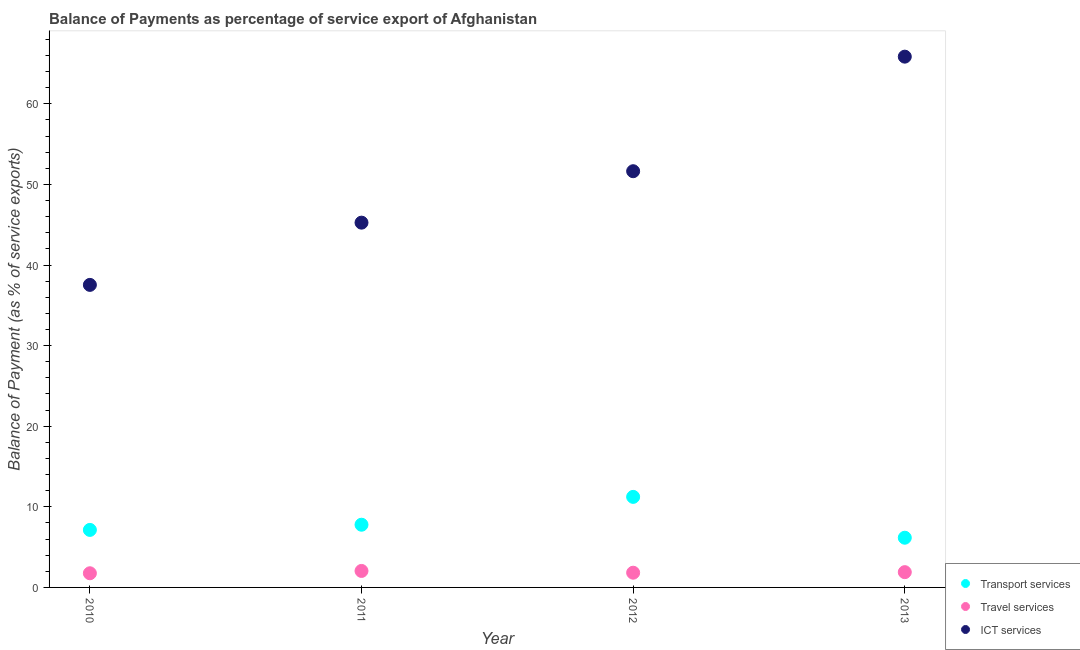How many different coloured dotlines are there?
Give a very brief answer. 3. Is the number of dotlines equal to the number of legend labels?
Keep it short and to the point. Yes. What is the balance of payment of travel services in 2011?
Provide a short and direct response. 2.05. Across all years, what is the maximum balance of payment of transport services?
Make the answer very short. 11.23. Across all years, what is the minimum balance of payment of travel services?
Give a very brief answer. 1.76. In which year was the balance of payment of travel services minimum?
Offer a very short reply. 2010. What is the total balance of payment of transport services in the graph?
Keep it short and to the point. 32.32. What is the difference between the balance of payment of ict services in 2011 and that in 2013?
Offer a very short reply. -20.59. What is the difference between the balance of payment of travel services in 2011 and the balance of payment of ict services in 2013?
Provide a succinct answer. -63.81. What is the average balance of payment of ict services per year?
Your response must be concise. 50.07. In the year 2013, what is the difference between the balance of payment of ict services and balance of payment of transport services?
Offer a terse response. 59.68. In how many years, is the balance of payment of travel services greater than 62 %?
Offer a terse response. 0. What is the ratio of the balance of payment of ict services in 2011 to that in 2013?
Offer a very short reply. 0.69. Is the difference between the balance of payment of travel services in 2011 and 2012 greater than the difference between the balance of payment of transport services in 2011 and 2012?
Give a very brief answer. Yes. What is the difference between the highest and the second highest balance of payment of ict services?
Offer a terse response. 14.21. What is the difference between the highest and the lowest balance of payment of ict services?
Your answer should be compact. 28.32. Is the sum of the balance of payment of travel services in 2010 and 2012 greater than the maximum balance of payment of ict services across all years?
Offer a terse response. No. Is it the case that in every year, the sum of the balance of payment of transport services and balance of payment of travel services is greater than the balance of payment of ict services?
Your answer should be very brief. No. Is the balance of payment of ict services strictly greater than the balance of payment of transport services over the years?
Keep it short and to the point. Yes. Is the balance of payment of travel services strictly less than the balance of payment of transport services over the years?
Your answer should be compact. Yes. What is the difference between two consecutive major ticks on the Y-axis?
Your answer should be very brief. 10. Are the values on the major ticks of Y-axis written in scientific E-notation?
Ensure brevity in your answer.  No. Where does the legend appear in the graph?
Your answer should be very brief. Bottom right. How many legend labels are there?
Your answer should be compact. 3. How are the legend labels stacked?
Provide a short and direct response. Vertical. What is the title of the graph?
Your answer should be compact. Balance of Payments as percentage of service export of Afghanistan. What is the label or title of the Y-axis?
Keep it short and to the point. Balance of Payment (as % of service exports). What is the Balance of Payment (as % of service exports) in Transport services in 2010?
Give a very brief answer. 7.14. What is the Balance of Payment (as % of service exports) in Travel services in 2010?
Make the answer very short. 1.76. What is the Balance of Payment (as % of service exports) in ICT services in 2010?
Keep it short and to the point. 37.53. What is the Balance of Payment (as % of service exports) of Transport services in 2011?
Make the answer very short. 7.78. What is the Balance of Payment (as % of service exports) of Travel services in 2011?
Keep it short and to the point. 2.05. What is the Balance of Payment (as % of service exports) in ICT services in 2011?
Ensure brevity in your answer.  45.26. What is the Balance of Payment (as % of service exports) of Transport services in 2012?
Your answer should be compact. 11.23. What is the Balance of Payment (as % of service exports) in Travel services in 2012?
Give a very brief answer. 1.83. What is the Balance of Payment (as % of service exports) of ICT services in 2012?
Make the answer very short. 51.64. What is the Balance of Payment (as % of service exports) in Transport services in 2013?
Make the answer very short. 6.17. What is the Balance of Payment (as % of service exports) of Travel services in 2013?
Give a very brief answer. 1.9. What is the Balance of Payment (as % of service exports) in ICT services in 2013?
Provide a succinct answer. 65.85. Across all years, what is the maximum Balance of Payment (as % of service exports) of Transport services?
Provide a short and direct response. 11.23. Across all years, what is the maximum Balance of Payment (as % of service exports) in Travel services?
Make the answer very short. 2.05. Across all years, what is the maximum Balance of Payment (as % of service exports) in ICT services?
Ensure brevity in your answer.  65.85. Across all years, what is the minimum Balance of Payment (as % of service exports) of Transport services?
Give a very brief answer. 6.17. Across all years, what is the minimum Balance of Payment (as % of service exports) in Travel services?
Keep it short and to the point. 1.76. Across all years, what is the minimum Balance of Payment (as % of service exports) of ICT services?
Ensure brevity in your answer.  37.53. What is the total Balance of Payment (as % of service exports) of Transport services in the graph?
Provide a succinct answer. 32.32. What is the total Balance of Payment (as % of service exports) in Travel services in the graph?
Make the answer very short. 7.52. What is the total Balance of Payment (as % of service exports) of ICT services in the graph?
Provide a short and direct response. 200.28. What is the difference between the Balance of Payment (as % of service exports) in Transport services in 2010 and that in 2011?
Your answer should be compact. -0.64. What is the difference between the Balance of Payment (as % of service exports) of Travel services in 2010 and that in 2011?
Your response must be concise. -0.29. What is the difference between the Balance of Payment (as % of service exports) in ICT services in 2010 and that in 2011?
Your answer should be very brief. -7.72. What is the difference between the Balance of Payment (as % of service exports) of Transport services in 2010 and that in 2012?
Your answer should be very brief. -4.1. What is the difference between the Balance of Payment (as % of service exports) in Travel services in 2010 and that in 2012?
Your response must be concise. -0.07. What is the difference between the Balance of Payment (as % of service exports) of ICT services in 2010 and that in 2012?
Your answer should be compact. -14.1. What is the difference between the Balance of Payment (as % of service exports) in Transport services in 2010 and that in 2013?
Give a very brief answer. 0.97. What is the difference between the Balance of Payment (as % of service exports) of Travel services in 2010 and that in 2013?
Provide a short and direct response. -0.14. What is the difference between the Balance of Payment (as % of service exports) in ICT services in 2010 and that in 2013?
Your answer should be compact. -28.32. What is the difference between the Balance of Payment (as % of service exports) in Transport services in 2011 and that in 2012?
Offer a terse response. -3.45. What is the difference between the Balance of Payment (as % of service exports) of Travel services in 2011 and that in 2012?
Make the answer very short. 0.22. What is the difference between the Balance of Payment (as % of service exports) in ICT services in 2011 and that in 2012?
Give a very brief answer. -6.38. What is the difference between the Balance of Payment (as % of service exports) of Transport services in 2011 and that in 2013?
Keep it short and to the point. 1.61. What is the difference between the Balance of Payment (as % of service exports) of Travel services in 2011 and that in 2013?
Offer a terse response. 0.15. What is the difference between the Balance of Payment (as % of service exports) in ICT services in 2011 and that in 2013?
Make the answer very short. -20.59. What is the difference between the Balance of Payment (as % of service exports) of Transport services in 2012 and that in 2013?
Make the answer very short. 5.07. What is the difference between the Balance of Payment (as % of service exports) in Travel services in 2012 and that in 2013?
Your answer should be compact. -0.07. What is the difference between the Balance of Payment (as % of service exports) in ICT services in 2012 and that in 2013?
Offer a terse response. -14.21. What is the difference between the Balance of Payment (as % of service exports) of Transport services in 2010 and the Balance of Payment (as % of service exports) of Travel services in 2011?
Keep it short and to the point. 5.09. What is the difference between the Balance of Payment (as % of service exports) in Transport services in 2010 and the Balance of Payment (as % of service exports) in ICT services in 2011?
Give a very brief answer. -38.12. What is the difference between the Balance of Payment (as % of service exports) of Travel services in 2010 and the Balance of Payment (as % of service exports) of ICT services in 2011?
Make the answer very short. -43.5. What is the difference between the Balance of Payment (as % of service exports) of Transport services in 2010 and the Balance of Payment (as % of service exports) of Travel services in 2012?
Make the answer very short. 5.31. What is the difference between the Balance of Payment (as % of service exports) in Transport services in 2010 and the Balance of Payment (as % of service exports) in ICT services in 2012?
Ensure brevity in your answer.  -44.5. What is the difference between the Balance of Payment (as % of service exports) of Travel services in 2010 and the Balance of Payment (as % of service exports) of ICT services in 2012?
Offer a terse response. -49.88. What is the difference between the Balance of Payment (as % of service exports) in Transport services in 2010 and the Balance of Payment (as % of service exports) in Travel services in 2013?
Keep it short and to the point. 5.24. What is the difference between the Balance of Payment (as % of service exports) in Transport services in 2010 and the Balance of Payment (as % of service exports) in ICT services in 2013?
Offer a very short reply. -58.71. What is the difference between the Balance of Payment (as % of service exports) in Travel services in 2010 and the Balance of Payment (as % of service exports) in ICT services in 2013?
Offer a terse response. -64.09. What is the difference between the Balance of Payment (as % of service exports) in Transport services in 2011 and the Balance of Payment (as % of service exports) in Travel services in 2012?
Provide a succinct answer. 5.95. What is the difference between the Balance of Payment (as % of service exports) of Transport services in 2011 and the Balance of Payment (as % of service exports) of ICT services in 2012?
Give a very brief answer. -43.86. What is the difference between the Balance of Payment (as % of service exports) in Travel services in 2011 and the Balance of Payment (as % of service exports) in ICT services in 2012?
Provide a succinct answer. -49.59. What is the difference between the Balance of Payment (as % of service exports) of Transport services in 2011 and the Balance of Payment (as % of service exports) of Travel services in 2013?
Offer a very short reply. 5.88. What is the difference between the Balance of Payment (as % of service exports) in Transport services in 2011 and the Balance of Payment (as % of service exports) in ICT services in 2013?
Give a very brief answer. -58.07. What is the difference between the Balance of Payment (as % of service exports) in Travel services in 2011 and the Balance of Payment (as % of service exports) in ICT services in 2013?
Provide a succinct answer. -63.81. What is the difference between the Balance of Payment (as % of service exports) in Transport services in 2012 and the Balance of Payment (as % of service exports) in Travel services in 2013?
Keep it short and to the point. 9.34. What is the difference between the Balance of Payment (as % of service exports) in Transport services in 2012 and the Balance of Payment (as % of service exports) in ICT services in 2013?
Keep it short and to the point. -54.62. What is the difference between the Balance of Payment (as % of service exports) in Travel services in 2012 and the Balance of Payment (as % of service exports) in ICT services in 2013?
Your response must be concise. -64.02. What is the average Balance of Payment (as % of service exports) in Transport services per year?
Provide a succinct answer. 8.08. What is the average Balance of Payment (as % of service exports) of Travel services per year?
Make the answer very short. 1.88. What is the average Balance of Payment (as % of service exports) of ICT services per year?
Make the answer very short. 50.07. In the year 2010, what is the difference between the Balance of Payment (as % of service exports) in Transport services and Balance of Payment (as % of service exports) in Travel services?
Ensure brevity in your answer.  5.38. In the year 2010, what is the difference between the Balance of Payment (as % of service exports) in Transport services and Balance of Payment (as % of service exports) in ICT services?
Provide a succinct answer. -30.4. In the year 2010, what is the difference between the Balance of Payment (as % of service exports) in Travel services and Balance of Payment (as % of service exports) in ICT services?
Make the answer very short. -35.78. In the year 2011, what is the difference between the Balance of Payment (as % of service exports) of Transport services and Balance of Payment (as % of service exports) of Travel services?
Give a very brief answer. 5.73. In the year 2011, what is the difference between the Balance of Payment (as % of service exports) of Transport services and Balance of Payment (as % of service exports) of ICT services?
Offer a terse response. -37.48. In the year 2011, what is the difference between the Balance of Payment (as % of service exports) of Travel services and Balance of Payment (as % of service exports) of ICT services?
Your answer should be very brief. -43.21. In the year 2012, what is the difference between the Balance of Payment (as % of service exports) of Transport services and Balance of Payment (as % of service exports) of Travel services?
Keep it short and to the point. 9.41. In the year 2012, what is the difference between the Balance of Payment (as % of service exports) of Transport services and Balance of Payment (as % of service exports) of ICT services?
Keep it short and to the point. -40.4. In the year 2012, what is the difference between the Balance of Payment (as % of service exports) in Travel services and Balance of Payment (as % of service exports) in ICT services?
Make the answer very short. -49.81. In the year 2013, what is the difference between the Balance of Payment (as % of service exports) of Transport services and Balance of Payment (as % of service exports) of Travel services?
Your response must be concise. 4.27. In the year 2013, what is the difference between the Balance of Payment (as % of service exports) of Transport services and Balance of Payment (as % of service exports) of ICT services?
Keep it short and to the point. -59.68. In the year 2013, what is the difference between the Balance of Payment (as % of service exports) in Travel services and Balance of Payment (as % of service exports) in ICT services?
Your answer should be very brief. -63.96. What is the ratio of the Balance of Payment (as % of service exports) in Transport services in 2010 to that in 2011?
Your answer should be very brief. 0.92. What is the ratio of the Balance of Payment (as % of service exports) in Travel services in 2010 to that in 2011?
Offer a terse response. 0.86. What is the ratio of the Balance of Payment (as % of service exports) in ICT services in 2010 to that in 2011?
Your answer should be very brief. 0.83. What is the ratio of the Balance of Payment (as % of service exports) of Transport services in 2010 to that in 2012?
Provide a succinct answer. 0.64. What is the ratio of the Balance of Payment (as % of service exports) of Travel services in 2010 to that in 2012?
Your answer should be compact. 0.96. What is the ratio of the Balance of Payment (as % of service exports) of ICT services in 2010 to that in 2012?
Offer a terse response. 0.73. What is the ratio of the Balance of Payment (as % of service exports) in Transport services in 2010 to that in 2013?
Ensure brevity in your answer.  1.16. What is the ratio of the Balance of Payment (as % of service exports) of Travel services in 2010 to that in 2013?
Make the answer very short. 0.93. What is the ratio of the Balance of Payment (as % of service exports) of ICT services in 2010 to that in 2013?
Give a very brief answer. 0.57. What is the ratio of the Balance of Payment (as % of service exports) in Transport services in 2011 to that in 2012?
Offer a terse response. 0.69. What is the ratio of the Balance of Payment (as % of service exports) of Travel services in 2011 to that in 2012?
Offer a very short reply. 1.12. What is the ratio of the Balance of Payment (as % of service exports) of ICT services in 2011 to that in 2012?
Your response must be concise. 0.88. What is the ratio of the Balance of Payment (as % of service exports) in Transport services in 2011 to that in 2013?
Offer a very short reply. 1.26. What is the ratio of the Balance of Payment (as % of service exports) of Travel services in 2011 to that in 2013?
Your response must be concise. 1.08. What is the ratio of the Balance of Payment (as % of service exports) of ICT services in 2011 to that in 2013?
Ensure brevity in your answer.  0.69. What is the ratio of the Balance of Payment (as % of service exports) in Transport services in 2012 to that in 2013?
Your answer should be compact. 1.82. What is the ratio of the Balance of Payment (as % of service exports) in Travel services in 2012 to that in 2013?
Offer a terse response. 0.96. What is the ratio of the Balance of Payment (as % of service exports) in ICT services in 2012 to that in 2013?
Ensure brevity in your answer.  0.78. What is the difference between the highest and the second highest Balance of Payment (as % of service exports) in Transport services?
Offer a very short reply. 3.45. What is the difference between the highest and the second highest Balance of Payment (as % of service exports) in Travel services?
Your response must be concise. 0.15. What is the difference between the highest and the second highest Balance of Payment (as % of service exports) in ICT services?
Offer a very short reply. 14.21. What is the difference between the highest and the lowest Balance of Payment (as % of service exports) in Transport services?
Provide a short and direct response. 5.07. What is the difference between the highest and the lowest Balance of Payment (as % of service exports) of Travel services?
Offer a very short reply. 0.29. What is the difference between the highest and the lowest Balance of Payment (as % of service exports) of ICT services?
Your answer should be very brief. 28.32. 